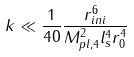<formula> <loc_0><loc_0><loc_500><loc_500>k \ll \frac { 1 } { 4 0 } \frac { r _ { i n i } ^ { 6 } } { M _ { p l , 4 } ^ { 2 } l _ { s } ^ { 4 } r _ { 0 } ^ { 4 } }</formula> 